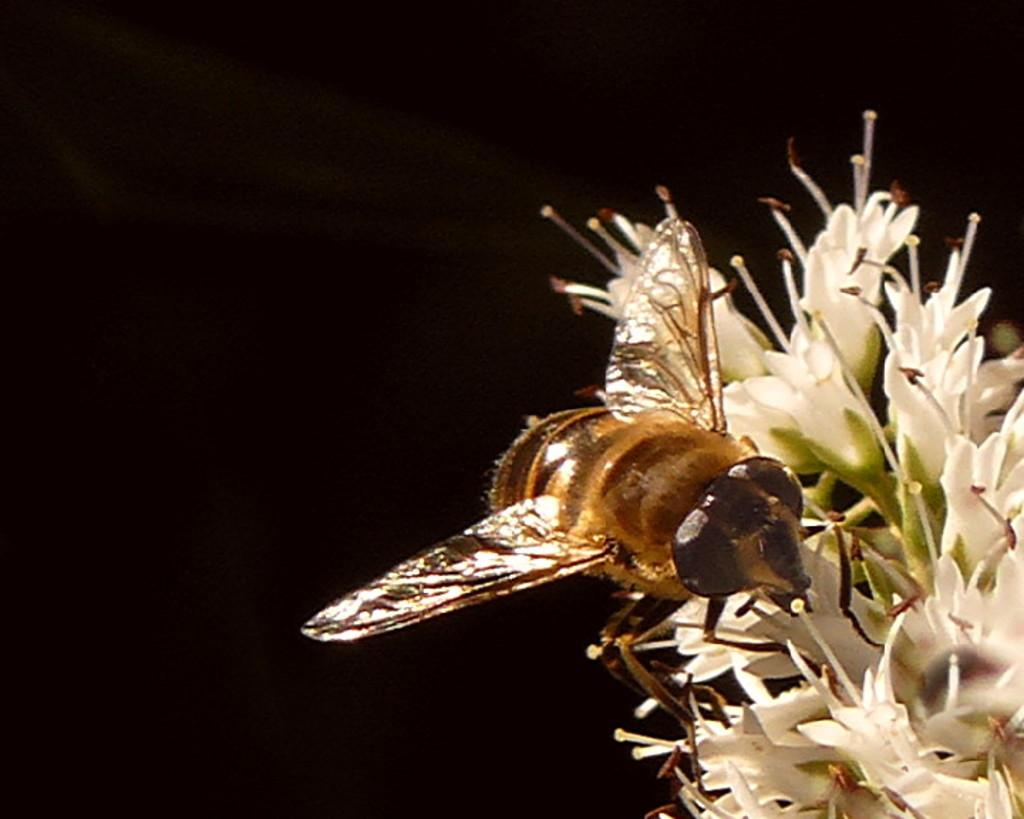What type of creature is in the image? There is an insect in the image. What is the insect doing in the image? The insect is on white flowers. Where is the insect located in the image? The insect is on the right side of the image. What is the color of the background in the image? The background of the image is dark. What type of fuel is the insect using to fly in the image? The insect does not appear to be flying in the image, and there is no mention of fuel. Additionally, insects do not use fuel to fly; they have wings and muscles that enable them to fly. 